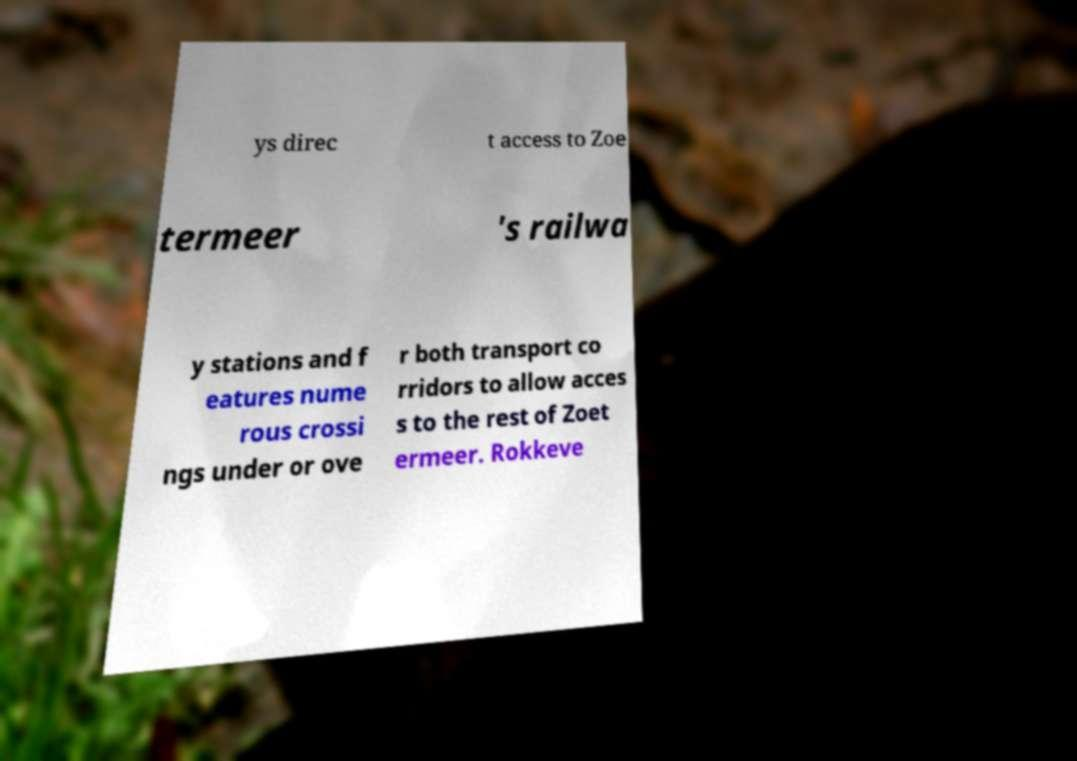There's text embedded in this image that I need extracted. Can you transcribe it verbatim? ys direc t access to Zoe termeer 's railwa y stations and f eatures nume rous crossi ngs under or ove r both transport co rridors to allow acces s to the rest of Zoet ermeer. Rokkeve 